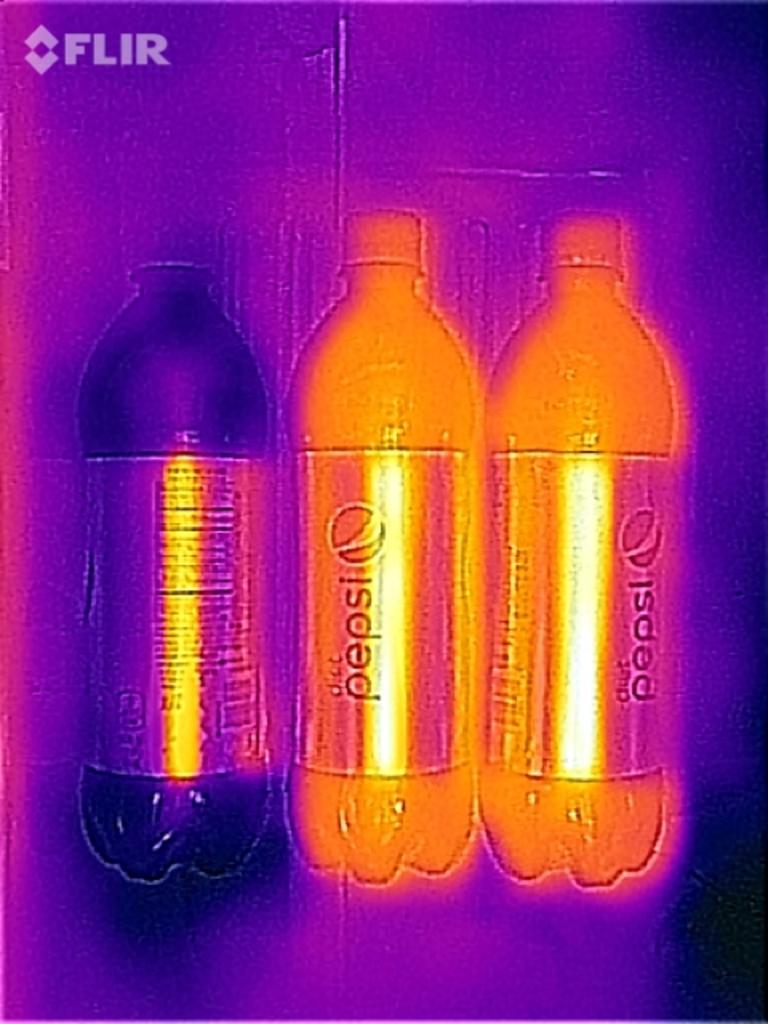What is this image service?
Your response must be concise. Flir. 